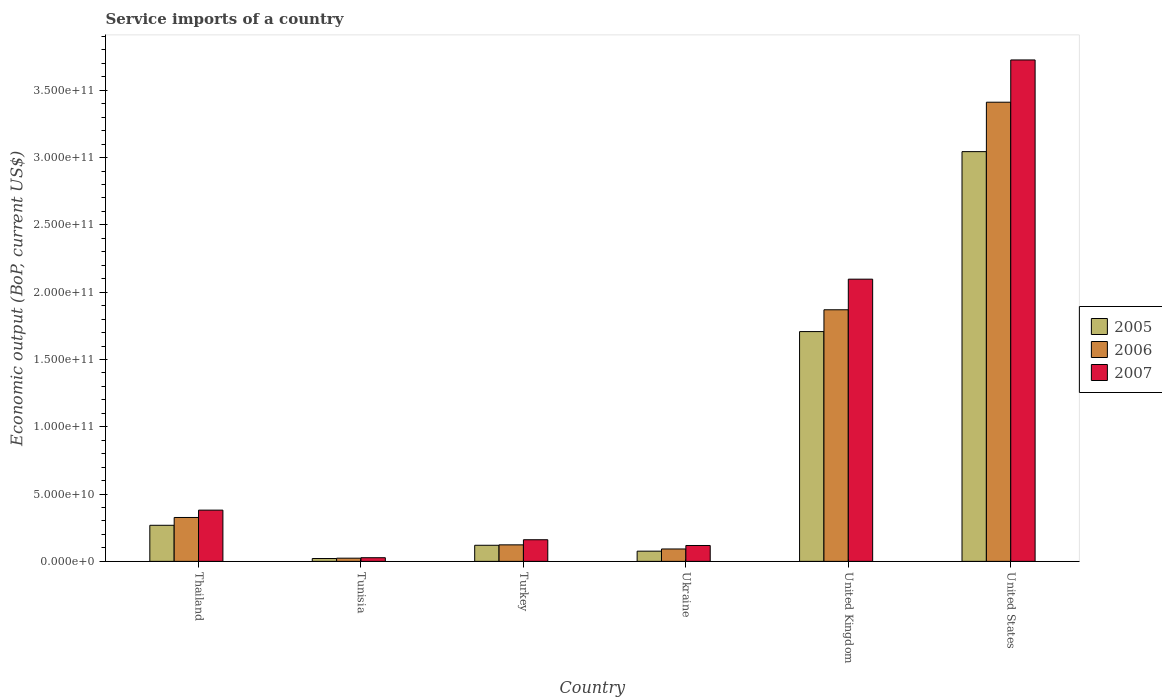How many different coloured bars are there?
Offer a very short reply. 3. What is the label of the 5th group of bars from the left?
Your answer should be very brief. United Kingdom. In how many cases, is the number of bars for a given country not equal to the number of legend labels?
Your response must be concise. 0. What is the service imports in 2005 in Ukraine?
Ensure brevity in your answer.  7.58e+09. Across all countries, what is the maximum service imports in 2005?
Your answer should be very brief. 3.04e+11. Across all countries, what is the minimum service imports in 2005?
Make the answer very short. 2.11e+09. In which country was the service imports in 2007 minimum?
Offer a very short reply. Tunisia. What is the total service imports in 2007 in the graph?
Offer a very short reply. 6.51e+11. What is the difference between the service imports in 2007 in Tunisia and that in Ukraine?
Offer a very short reply. -9.08e+09. What is the difference between the service imports in 2006 in Thailand and the service imports in 2005 in Ukraine?
Make the answer very short. 2.50e+1. What is the average service imports in 2005 per country?
Your answer should be very brief. 8.73e+1. What is the difference between the service imports of/in 2006 and service imports of/in 2005 in United Kingdom?
Give a very brief answer. 1.62e+1. What is the ratio of the service imports in 2005 in Tunisia to that in Turkey?
Give a very brief answer. 0.18. Is the service imports in 2006 in Turkey less than that in Ukraine?
Keep it short and to the point. No. Is the difference between the service imports in 2006 in Turkey and United States greater than the difference between the service imports in 2005 in Turkey and United States?
Ensure brevity in your answer.  No. What is the difference between the highest and the second highest service imports in 2006?
Provide a succinct answer. 1.54e+11. What is the difference between the highest and the lowest service imports in 2006?
Ensure brevity in your answer.  3.39e+11. Is the sum of the service imports in 2007 in Thailand and Turkey greater than the maximum service imports in 2005 across all countries?
Offer a terse response. No. Are all the bars in the graph horizontal?
Your answer should be very brief. No. What is the difference between two consecutive major ticks on the Y-axis?
Offer a very short reply. 5.00e+1. Are the values on the major ticks of Y-axis written in scientific E-notation?
Offer a very short reply. Yes. Does the graph contain any zero values?
Offer a terse response. No. Does the graph contain grids?
Your response must be concise. No. Where does the legend appear in the graph?
Your answer should be very brief. Center right. How are the legend labels stacked?
Provide a succinct answer. Vertical. What is the title of the graph?
Provide a succinct answer. Service imports of a country. What is the label or title of the Y-axis?
Your response must be concise. Economic output (BoP, current US$). What is the Economic output (BoP, current US$) in 2005 in Thailand?
Ensure brevity in your answer.  2.68e+1. What is the Economic output (BoP, current US$) of 2006 in Thailand?
Provide a succinct answer. 3.26e+1. What is the Economic output (BoP, current US$) of 2007 in Thailand?
Ensure brevity in your answer.  3.81e+1. What is the Economic output (BoP, current US$) of 2005 in Tunisia?
Offer a very short reply. 2.11e+09. What is the Economic output (BoP, current US$) of 2006 in Tunisia?
Make the answer very short. 2.36e+09. What is the Economic output (BoP, current US$) of 2007 in Tunisia?
Keep it short and to the point. 2.71e+09. What is the Economic output (BoP, current US$) of 2005 in Turkey?
Offer a very short reply. 1.20e+1. What is the Economic output (BoP, current US$) in 2006 in Turkey?
Provide a succinct answer. 1.23e+1. What is the Economic output (BoP, current US$) of 2007 in Turkey?
Offer a terse response. 1.61e+1. What is the Economic output (BoP, current US$) of 2005 in Ukraine?
Offer a terse response. 7.58e+09. What is the Economic output (BoP, current US$) in 2006 in Ukraine?
Your answer should be very brief. 9.20e+09. What is the Economic output (BoP, current US$) of 2007 in Ukraine?
Ensure brevity in your answer.  1.18e+1. What is the Economic output (BoP, current US$) in 2005 in United Kingdom?
Keep it short and to the point. 1.71e+11. What is the Economic output (BoP, current US$) of 2006 in United Kingdom?
Give a very brief answer. 1.87e+11. What is the Economic output (BoP, current US$) in 2007 in United Kingdom?
Give a very brief answer. 2.10e+11. What is the Economic output (BoP, current US$) in 2005 in United States?
Ensure brevity in your answer.  3.04e+11. What is the Economic output (BoP, current US$) in 2006 in United States?
Offer a terse response. 3.41e+11. What is the Economic output (BoP, current US$) in 2007 in United States?
Keep it short and to the point. 3.73e+11. Across all countries, what is the maximum Economic output (BoP, current US$) in 2005?
Your answer should be very brief. 3.04e+11. Across all countries, what is the maximum Economic output (BoP, current US$) of 2006?
Offer a terse response. 3.41e+11. Across all countries, what is the maximum Economic output (BoP, current US$) in 2007?
Your response must be concise. 3.73e+11. Across all countries, what is the minimum Economic output (BoP, current US$) of 2005?
Give a very brief answer. 2.11e+09. Across all countries, what is the minimum Economic output (BoP, current US$) of 2006?
Keep it short and to the point. 2.36e+09. Across all countries, what is the minimum Economic output (BoP, current US$) in 2007?
Ensure brevity in your answer.  2.71e+09. What is the total Economic output (BoP, current US$) of 2005 in the graph?
Your answer should be compact. 5.24e+11. What is the total Economic output (BoP, current US$) in 2006 in the graph?
Offer a terse response. 5.85e+11. What is the total Economic output (BoP, current US$) in 2007 in the graph?
Provide a short and direct response. 6.51e+11. What is the difference between the Economic output (BoP, current US$) in 2005 in Thailand and that in Tunisia?
Provide a succinct answer. 2.47e+1. What is the difference between the Economic output (BoP, current US$) of 2006 in Thailand and that in Tunisia?
Offer a terse response. 3.02e+1. What is the difference between the Economic output (BoP, current US$) in 2007 in Thailand and that in Tunisia?
Ensure brevity in your answer.  3.54e+1. What is the difference between the Economic output (BoP, current US$) of 2005 in Thailand and that in Turkey?
Your answer should be compact. 1.49e+1. What is the difference between the Economic output (BoP, current US$) in 2006 in Thailand and that in Turkey?
Ensure brevity in your answer.  2.03e+1. What is the difference between the Economic output (BoP, current US$) of 2007 in Thailand and that in Turkey?
Give a very brief answer. 2.20e+1. What is the difference between the Economic output (BoP, current US$) in 2005 in Thailand and that in Ukraine?
Offer a terse response. 1.92e+1. What is the difference between the Economic output (BoP, current US$) of 2006 in Thailand and that in Ukraine?
Ensure brevity in your answer.  2.34e+1. What is the difference between the Economic output (BoP, current US$) in 2007 in Thailand and that in Ukraine?
Your answer should be very brief. 2.63e+1. What is the difference between the Economic output (BoP, current US$) of 2005 in Thailand and that in United Kingdom?
Provide a succinct answer. -1.44e+11. What is the difference between the Economic output (BoP, current US$) in 2006 in Thailand and that in United Kingdom?
Give a very brief answer. -1.54e+11. What is the difference between the Economic output (BoP, current US$) of 2007 in Thailand and that in United Kingdom?
Your answer should be compact. -1.72e+11. What is the difference between the Economic output (BoP, current US$) of 2005 in Thailand and that in United States?
Your answer should be compact. -2.78e+11. What is the difference between the Economic output (BoP, current US$) in 2006 in Thailand and that in United States?
Provide a succinct answer. -3.09e+11. What is the difference between the Economic output (BoP, current US$) in 2007 in Thailand and that in United States?
Provide a succinct answer. -3.35e+11. What is the difference between the Economic output (BoP, current US$) in 2005 in Tunisia and that in Turkey?
Provide a short and direct response. -9.84e+09. What is the difference between the Economic output (BoP, current US$) of 2006 in Tunisia and that in Turkey?
Your response must be concise. -9.91e+09. What is the difference between the Economic output (BoP, current US$) in 2007 in Tunisia and that in Turkey?
Your answer should be very brief. -1.34e+1. What is the difference between the Economic output (BoP, current US$) in 2005 in Tunisia and that in Ukraine?
Offer a very short reply. -5.47e+09. What is the difference between the Economic output (BoP, current US$) in 2006 in Tunisia and that in Ukraine?
Your answer should be compact. -6.84e+09. What is the difference between the Economic output (BoP, current US$) in 2007 in Tunisia and that in Ukraine?
Offer a terse response. -9.08e+09. What is the difference between the Economic output (BoP, current US$) of 2005 in Tunisia and that in United Kingdom?
Keep it short and to the point. -1.69e+11. What is the difference between the Economic output (BoP, current US$) in 2006 in Tunisia and that in United Kingdom?
Give a very brief answer. -1.85e+11. What is the difference between the Economic output (BoP, current US$) in 2007 in Tunisia and that in United Kingdom?
Ensure brevity in your answer.  -2.07e+11. What is the difference between the Economic output (BoP, current US$) of 2005 in Tunisia and that in United States?
Give a very brief answer. -3.02e+11. What is the difference between the Economic output (BoP, current US$) in 2006 in Tunisia and that in United States?
Ensure brevity in your answer.  -3.39e+11. What is the difference between the Economic output (BoP, current US$) of 2007 in Tunisia and that in United States?
Offer a very short reply. -3.70e+11. What is the difference between the Economic output (BoP, current US$) of 2005 in Turkey and that in Ukraine?
Your response must be concise. 4.38e+09. What is the difference between the Economic output (BoP, current US$) of 2006 in Turkey and that in Ukraine?
Give a very brief answer. 3.06e+09. What is the difference between the Economic output (BoP, current US$) of 2007 in Turkey and that in Ukraine?
Your answer should be compact. 4.28e+09. What is the difference between the Economic output (BoP, current US$) in 2005 in Turkey and that in United Kingdom?
Your answer should be compact. -1.59e+11. What is the difference between the Economic output (BoP, current US$) of 2006 in Turkey and that in United Kingdom?
Give a very brief answer. -1.75e+11. What is the difference between the Economic output (BoP, current US$) in 2007 in Turkey and that in United Kingdom?
Your answer should be compact. -1.94e+11. What is the difference between the Economic output (BoP, current US$) of 2005 in Turkey and that in United States?
Your response must be concise. -2.93e+11. What is the difference between the Economic output (BoP, current US$) in 2006 in Turkey and that in United States?
Provide a short and direct response. -3.29e+11. What is the difference between the Economic output (BoP, current US$) of 2007 in Turkey and that in United States?
Your answer should be compact. -3.57e+11. What is the difference between the Economic output (BoP, current US$) in 2005 in Ukraine and that in United Kingdom?
Offer a terse response. -1.63e+11. What is the difference between the Economic output (BoP, current US$) in 2006 in Ukraine and that in United Kingdom?
Provide a succinct answer. -1.78e+11. What is the difference between the Economic output (BoP, current US$) in 2007 in Ukraine and that in United Kingdom?
Make the answer very short. -1.98e+11. What is the difference between the Economic output (BoP, current US$) of 2005 in Ukraine and that in United States?
Your answer should be very brief. -2.97e+11. What is the difference between the Economic output (BoP, current US$) in 2006 in Ukraine and that in United States?
Ensure brevity in your answer.  -3.32e+11. What is the difference between the Economic output (BoP, current US$) of 2007 in Ukraine and that in United States?
Give a very brief answer. -3.61e+11. What is the difference between the Economic output (BoP, current US$) in 2005 in United Kingdom and that in United States?
Make the answer very short. -1.34e+11. What is the difference between the Economic output (BoP, current US$) of 2006 in United Kingdom and that in United States?
Ensure brevity in your answer.  -1.54e+11. What is the difference between the Economic output (BoP, current US$) of 2007 in United Kingdom and that in United States?
Give a very brief answer. -1.63e+11. What is the difference between the Economic output (BoP, current US$) in 2005 in Thailand and the Economic output (BoP, current US$) in 2006 in Tunisia?
Make the answer very short. 2.44e+1. What is the difference between the Economic output (BoP, current US$) in 2005 in Thailand and the Economic output (BoP, current US$) in 2007 in Tunisia?
Offer a terse response. 2.41e+1. What is the difference between the Economic output (BoP, current US$) of 2006 in Thailand and the Economic output (BoP, current US$) of 2007 in Tunisia?
Provide a short and direct response. 2.99e+1. What is the difference between the Economic output (BoP, current US$) in 2005 in Thailand and the Economic output (BoP, current US$) in 2006 in Turkey?
Make the answer very short. 1.45e+1. What is the difference between the Economic output (BoP, current US$) in 2005 in Thailand and the Economic output (BoP, current US$) in 2007 in Turkey?
Your answer should be very brief. 1.07e+1. What is the difference between the Economic output (BoP, current US$) of 2006 in Thailand and the Economic output (BoP, current US$) of 2007 in Turkey?
Offer a terse response. 1.65e+1. What is the difference between the Economic output (BoP, current US$) in 2005 in Thailand and the Economic output (BoP, current US$) in 2006 in Ukraine?
Make the answer very short. 1.76e+1. What is the difference between the Economic output (BoP, current US$) in 2005 in Thailand and the Economic output (BoP, current US$) in 2007 in Ukraine?
Offer a very short reply. 1.50e+1. What is the difference between the Economic output (BoP, current US$) of 2006 in Thailand and the Economic output (BoP, current US$) of 2007 in Ukraine?
Offer a terse response. 2.08e+1. What is the difference between the Economic output (BoP, current US$) in 2005 in Thailand and the Economic output (BoP, current US$) in 2006 in United Kingdom?
Make the answer very short. -1.60e+11. What is the difference between the Economic output (BoP, current US$) of 2005 in Thailand and the Economic output (BoP, current US$) of 2007 in United Kingdom?
Your answer should be compact. -1.83e+11. What is the difference between the Economic output (BoP, current US$) in 2006 in Thailand and the Economic output (BoP, current US$) in 2007 in United Kingdom?
Keep it short and to the point. -1.77e+11. What is the difference between the Economic output (BoP, current US$) in 2005 in Thailand and the Economic output (BoP, current US$) in 2006 in United States?
Give a very brief answer. -3.14e+11. What is the difference between the Economic output (BoP, current US$) in 2005 in Thailand and the Economic output (BoP, current US$) in 2007 in United States?
Provide a succinct answer. -3.46e+11. What is the difference between the Economic output (BoP, current US$) in 2006 in Thailand and the Economic output (BoP, current US$) in 2007 in United States?
Keep it short and to the point. -3.40e+11. What is the difference between the Economic output (BoP, current US$) in 2005 in Tunisia and the Economic output (BoP, current US$) in 2006 in Turkey?
Offer a terse response. -1.02e+1. What is the difference between the Economic output (BoP, current US$) in 2005 in Tunisia and the Economic output (BoP, current US$) in 2007 in Turkey?
Your answer should be compact. -1.40e+1. What is the difference between the Economic output (BoP, current US$) in 2006 in Tunisia and the Economic output (BoP, current US$) in 2007 in Turkey?
Give a very brief answer. -1.37e+1. What is the difference between the Economic output (BoP, current US$) of 2005 in Tunisia and the Economic output (BoP, current US$) of 2006 in Ukraine?
Provide a succinct answer. -7.10e+09. What is the difference between the Economic output (BoP, current US$) of 2005 in Tunisia and the Economic output (BoP, current US$) of 2007 in Ukraine?
Ensure brevity in your answer.  -9.68e+09. What is the difference between the Economic output (BoP, current US$) in 2006 in Tunisia and the Economic output (BoP, current US$) in 2007 in Ukraine?
Offer a terse response. -9.43e+09. What is the difference between the Economic output (BoP, current US$) of 2005 in Tunisia and the Economic output (BoP, current US$) of 2006 in United Kingdom?
Give a very brief answer. -1.85e+11. What is the difference between the Economic output (BoP, current US$) of 2005 in Tunisia and the Economic output (BoP, current US$) of 2007 in United Kingdom?
Make the answer very short. -2.08e+11. What is the difference between the Economic output (BoP, current US$) in 2006 in Tunisia and the Economic output (BoP, current US$) in 2007 in United Kingdom?
Your answer should be compact. -2.07e+11. What is the difference between the Economic output (BoP, current US$) of 2005 in Tunisia and the Economic output (BoP, current US$) of 2006 in United States?
Your answer should be very brief. -3.39e+11. What is the difference between the Economic output (BoP, current US$) in 2005 in Tunisia and the Economic output (BoP, current US$) in 2007 in United States?
Provide a succinct answer. -3.70e+11. What is the difference between the Economic output (BoP, current US$) of 2006 in Tunisia and the Economic output (BoP, current US$) of 2007 in United States?
Offer a terse response. -3.70e+11. What is the difference between the Economic output (BoP, current US$) in 2005 in Turkey and the Economic output (BoP, current US$) in 2006 in Ukraine?
Your answer should be very brief. 2.74e+09. What is the difference between the Economic output (BoP, current US$) in 2005 in Turkey and the Economic output (BoP, current US$) in 2007 in Ukraine?
Ensure brevity in your answer.  1.60e+08. What is the difference between the Economic output (BoP, current US$) of 2006 in Turkey and the Economic output (BoP, current US$) of 2007 in Ukraine?
Provide a succinct answer. 4.78e+08. What is the difference between the Economic output (BoP, current US$) of 2005 in Turkey and the Economic output (BoP, current US$) of 2006 in United Kingdom?
Offer a very short reply. -1.75e+11. What is the difference between the Economic output (BoP, current US$) of 2005 in Turkey and the Economic output (BoP, current US$) of 2007 in United Kingdom?
Your answer should be compact. -1.98e+11. What is the difference between the Economic output (BoP, current US$) in 2006 in Turkey and the Economic output (BoP, current US$) in 2007 in United Kingdom?
Offer a very short reply. -1.97e+11. What is the difference between the Economic output (BoP, current US$) in 2005 in Turkey and the Economic output (BoP, current US$) in 2006 in United States?
Offer a very short reply. -3.29e+11. What is the difference between the Economic output (BoP, current US$) of 2005 in Turkey and the Economic output (BoP, current US$) of 2007 in United States?
Provide a short and direct response. -3.61e+11. What is the difference between the Economic output (BoP, current US$) in 2006 in Turkey and the Economic output (BoP, current US$) in 2007 in United States?
Provide a succinct answer. -3.60e+11. What is the difference between the Economic output (BoP, current US$) in 2005 in Ukraine and the Economic output (BoP, current US$) in 2006 in United Kingdom?
Provide a succinct answer. -1.79e+11. What is the difference between the Economic output (BoP, current US$) of 2005 in Ukraine and the Economic output (BoP, current US$) of 2007 in United Kingdom?
Give a very brief answer. -2.02e+11. What is the difference between the Economic output (BoP, current US$) of 2006 in Ukraine and the Economic output (BoP, current US$) of 2007 in United Kingdom?
Your answer should be very brief. -2.00e+11. What is the difference between the Economic output (BoP, current US$) in 2005 in Ukraine and the Economic output (BoP, current US$) in 2006 in United States?
Your response must be concise. -3.34e+11. What is the difference between the Economic output (BoP, current US$) in 2005 in Ukraine and the Economic output (BoP, current US$) in 2007 in United States?
Give a very brief answer. -3.65e+11. What is the difference between the Economic output (BoP, current US$) in 2006 in Ukraine and the Economic output (BoP, current US$) in 2007 in United States?
Ensure brevity in your answer.  -3.63e+11. What is the difference between the Economic output (BoP, current US$) of 2005 in United Kingdom and the Economic output (BoP, current US$) of 2006 in United States?
Your answer should be compact. -1.70e+11. What is the difference between the Economic output (BoP, current US$) in 2005 in United Kingdom and the Economic output (BoP, current US$) in 2007 in United States?
Your answer should be very brief. -2.02e+11. What is the difference between the Economic output (BoP, current US$) of 2006 in United Kingdom and the Economic output (BoP, current US$) of 2007 in United States?
Provide a succinct answer. -1.86e+11. What is the average Economic output (BoP, current US$) of 2005 per country?
Offer a very short reply. 8.73e+1. What is the average Economic output (BoP, current US$) in 2006 per country?
Provide a succinct answer. 9.74e+1. What is the average Economic output (BoP, current US$) of 2007 per country?
Make the answer very short. 1.08e+11. What is the difference between the Economic output (BoP, current US$) in 2005 and Economic output (BoP, current US$) in 2006 in Thailand?
Ensure brevity in your answer.  -5.80e+09. What is the difference between the Economic output (BoP, current US$) in 2005 and Economic output (BoP, current US$) in 2007 in Thailand?
Provide a succinct answer. -1.13e+1. What is the difference between the Economic output (BoP, current US$) of 2006 and Economic output (BoP, current US$) of 2007 in Thailand?
Make the answer very short. -5.46e+09. What is the difference between the Economic output (BoP, current US$) of 2005 and Economic output (BoP, current US$) of 2006 in Tunisia?
Provide a short and direct response. -2.55e+08. What is the difference between the Economic output (BoP, current US$) of 2005 and Economic output (BoP, current US$) of 2007 in Tunisia?
Ensure brevity in your answer.  -6.03e+08. What is the difference between the Economic output (BoP, current US$) in 2006 and Economic output (BoP, current US$) in 2007 in Tunisia?
Keep it short and to the point. -3.48e+08. What is the difference between the Economic output (BoP, current US$) of 2005 and Economic output (BoP, current US$) of 2006 in Turkey?
Provide a short and direct response. -3.18e+08. What is the difference between the Economic output (BoP, current US$) of 2005 and Economic output (BoP, current US$) of 2007 in Turkey?
Offer a very short reply. -4.12e+09. What is the difference between the Economic output (BoP, current US$) of 2006 and Economic output (BoP, current US$) of 2007 in Turkey?
Make the answer very short. -3.80e+09. What is the difference between the Economic output (BoP, current US$) in 2005 and Economic output (BoP, current US$) in 2006 in Ukraine?
Make the answer very short. -1.63e+09. What is the difference between the Economic output (BoP, current US$) of 2005 and Economic output (BoP, current US$) of 2007 in Ukraine?
Your answer should be very brief. -4.22e+09. What is the difference between the Economic output (BoP, current US$) of 2006 and Economic output (BoP, current US$) of 2007 in Ukraine?
Offer a terse response. -2.58e+09. What is the difference between the Economic output (BoP, current US$) of 2005 and Economic output (BoP, current US$) of 2006 in United Kingdom?
Give a very brief answer. -1.62e+1. What is the difference between the Economic output (BoP, current US$) in 2005 and Economic output (BoP, current US$) in 2007 in United Kingdom?
Give a very brief answer. -3.89e+1. What is the difference between the Economic output (BoP, current US$) in 2006 and Economic output (BoP, current US$) in 2007 in United Kingdom?
Your response must be concise. -2.27e+1. What is the difference between the Economic output (BoP, current US$) in 2005 and Economic output (BoP, current US$) in 2006 in United States?
Make the answer very short. -3.67e+1. What is the difference between the Economic output (BoP, current US$) of 2005 and Economic output (BoP, current US$) of 2007 in United States?
Your answer should be very brief. -6.81e+1. What is the difference between the Economic output (BoP, current US$) of 2006 and Economic output (BoP, current US$) of 2007 in United States?
Your answer should be compact. -3.14e+1. What is the ratio of the Economic output (BoP, current US$) of 2005 in Thailand to that in Tunisia?
Your answer should be very brief. 12.72. What is the ratio of the Economic output (BoP, current US$) in 2006 in Thailand to that in Tunisia?
Make the answer very short. 13.8. What is the ratio of the Economic output (BoP, current US$) in 2007 in Thailand to that in Tunisia?
Keep it short and to the point. 14.05. What is the ratio of the Economic output (BoP, current US$) in 2005 in Thailand to that in Turkey?
Offer a terse response. 2.24. What is the ratio of the Economic output (BoP, current US$) in 2006 in Thailand to that in Turkey?
Give a very brief answer. 2.66. What is the ratio of the Economic output (BoP, current US$) of 2007 in Thailand to that in Turkey?
Provide a succinct answer. 2.37. What is the ratio of the Economic output (BoP, current US$) in 2005 in Thailand to that in Ukraine?
Your answer should be very brief. 3.54. What is the ratio of the Economic output (BoP, current US$) in 2006 in Thailand to that in Ukraine?
Give a very brief answer. 3.54. What is the ratio of the Economic output (BoP, current US$) in 2007 in Thailand to that in Ukraine?
Offer a very short reply. 3.23. What is the ratio of the Economic output (BoP, current US$) of 2005 in Thailand to that in United Kingdom?
Provide a succinct answer. 0.16. What is the ratio of the Economic output (BoP, current US$) in 2006 in Thailand to that in United Kingdom?
Make the answer very short. 0.17. What is the ratio of the Economic output (BoP, current US$) of 2007 in Thailand to that in United Kingdom?
Ensure brevity in your answer.  0.18. What is the ratio of the Economic output (BoP, current US$) of 2005 in Thailand to that in United States?
Offer a terse response. 0.09. What is the ratio of the Economic output (BoP, current US$) of 2006 in Thailand to that in United States?
Give a very brief answer. 0.1. What is the ratio of the Economic output (BoP, current US$) of 2007 in Thailand to that in United States?
Make the answer very short. 0.1. What is the ratio of the Economic output (BoP, current US$) in 2005 in Tunisia to that in Turkey?
Offer a terse response. 0.18. What is the ratio of the Economic output (BoP, current US$) in 2006 in Tunisia to that in Turkey?
Give a very brief answer. 0.19. What is the ratio of the Economic output (BoP, current US$) of 2007 in Tunisia to that in Turkey?
Keep it short and to the point. 0.17. What is the ratio of the Economic output (BoP, current US$) in 2005 in Tunisia to that in Ukraine?
Offer a very short reply. 0.28. What is the ratio of the Economic output (BoP, current US$) of 2006 in Tunisia to that in Ukraine?
Offer a very short reply. 0.26. What is the ratio of the Economic output (BoP, current US$) in 2007 in Tunisia to that in Ukraine?
Your answer should be very brief. 0.23. What is the ratio of the Economic output (BoP, current US$) of 2005 in Tunisia to that in United Kingdom?
Provide a short and direct response. 0.01. What is the ratio of the Economic output (BoP, current US$) of 2006 in Tunisia to that in United Kingdom?
Your response must be concise. 0.01. What is the ratio of the Economic output (BoP, current US$) of 2007 in Tunisia to that in United Kingdom?
Offer a terse response. 0.01. What is the ratio of the Economic output (BoP, current US$) in 2005 in Tunisia to that in United States?
Offer a very short reply. 0.01. What is the ratio of the Economic output (BoP, current US$) in 2006 in Tunisia to that in United States?
Your answer should be compact. 0.01. What is the ratio of the Economic output (BoP, current US$) in 2007 in Tunisia to that in United States?
Your response must be concise. 0.01. What is the ratio of the Economic output (BoP, current US$) in 2005 in Turkey to that in Ukraine?
Give a very brief answer. 1.58. What is the ratio of the Economic output (BoP, current US$) in 2006 in Turkey to that in Ukraine?
Offer a terse response. 1.33. What is the ratio of the Economic output (BoP, current US$) of 2007 in Turkey to that in Ukraine?
Your response must be concise. 1.36. What is the ratio of the Economic output (BoP, current US$) of 2005 in Turkey to that in United Kingdom?
Ensure brevity in your answer.  0.07. What is the ratio of the Economic output (BoP, current US$) in 2006 in Turkey to that in United Kingdom?
Your answer should be very brief. 0.07. What is the ratio of the Economic output (BoP, current US$) of 2007 in Turkey to that in United Kingdom?
Ensure brevity in your answer.  0.08. What is the ratio of the Economic output (BoP, current US$) in 2005 in Turkey to that in United States?
Keep it short and to the point. 0.04. What is the ratio of the Economic output (BoP, current US$) of 2006 in Turkey to that in United States?
Your answer should be compact. 0.04. What is the ratio of the Economic output (BoP, current US$) of 2007 in Turkey to that in United States?
Keep it short and to the point. 0.04. What is the ratio of the Economic output (BoP, current US$) of 2005 in Ukraine to that in United Kingdom?
Offer a very short reply. 0.04. What is the ratio of the Economic output (BoP, current US$) in 2006 in Ukraine to that in United Kingdom?
Keep it short and to the point. 0.05. What is the ratio of the Economic output (BoP, current US$) in 2007 in Ukraine to that in United Kingdom?
Your answer should be compact. 0.06. What is the ratio of the Economic output (BoP, current US$) of 2005 in Ukraine to that in United States?
Offer a very short reply. 0.02. What is the ratio of the Economic output (BoP, current US$) of 2006 in Ukraine to that in United States?
Make the answer very short. 0.03. What is the ratio of the Economic output (BoP, current US$) of 2007 in Ukraine to that in United States?
Offer a terse response. 0.03. What is the ratio of the Economic output (BoP, current US$) in 2005 in United Kingdom to that in United States?
Give a very brief answer. 0.56. What is the ratio of the Economic output (BoP, current US$) in 2006 in United Kingdom to that in United States?
Your response must be concise. 0.55. What is the ratio of the Economic output (BoP, current US$) in 2007 in United Kingdom to that in United States?
Keep it short and to the point. 0.56. What is the difference between the highest and the second highest Economic output (BoP, current US$) of 2005?
Keep it short and to the point. 1.34e+11. What is the difference between the highest and the second highest Economic output (BoP, current US$) in 2006?
Your answer should be very brief. 1.54e+11. What is the difference between the highest and the second highest Economic output (BoP, current US$) of 2007?
Offer a terse response. 1.63e+11. What is the difference between the highest and the lowest Economic output (BoP, current US$) in 2005?
Keep it short and to the point. 3.02e+11. What is the difference between the highest and the lowest Economic output (BoP, current US$) of 2006?
Offer a terse response. 3.39e+11. What is the difference between the highest and the lowest Economic output (BoP, current US$) in 2007?
Your answer should be very brief. 3.70e+11. 